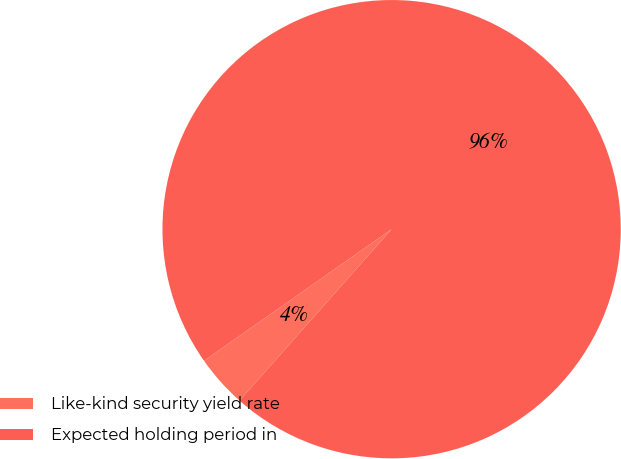Convert chart to OTSL. <chart><loc_0><loc_0><loc_500><loc_500><pie_chart><fcel>Like-kind security yield rate<fcel>Expected holding period in<nl><fcel>3.71%<fcel>96.29%<nl></chart> 